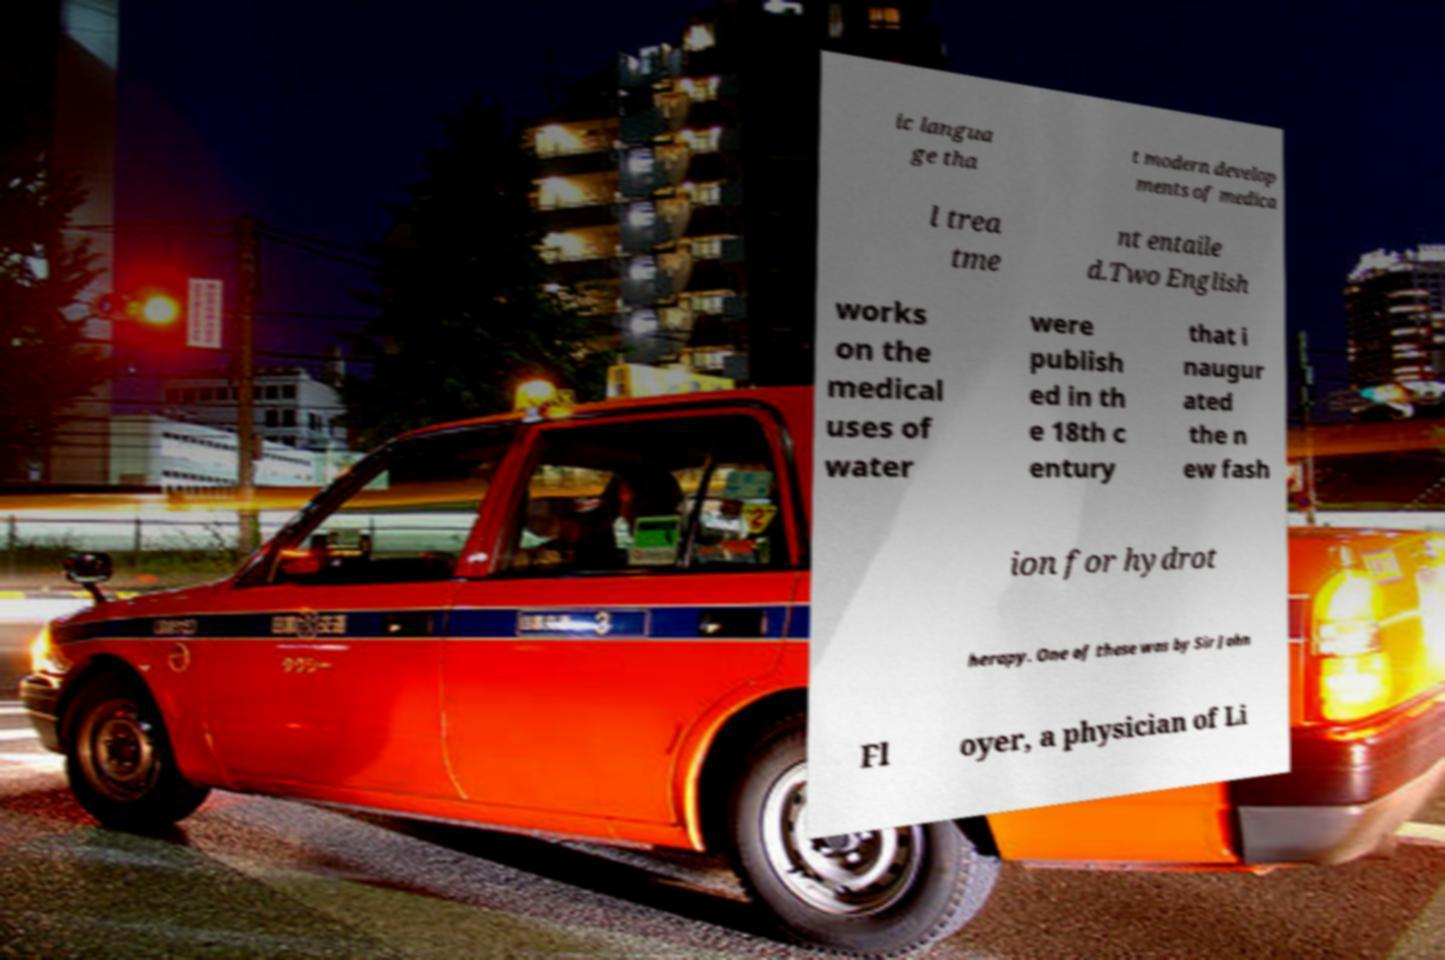Could you assist in decoding the text presented in this image and type it out clearly? ic langua ge tha t modern develop ments of medica l trea tme nt entaile d.Two English works on the medical uses of water were publish ed in th e 18th c entury that i naugur ated the n ew fash ion for hydrot herapy. One of these was by Sir John Fl oyer, a physician of Li 